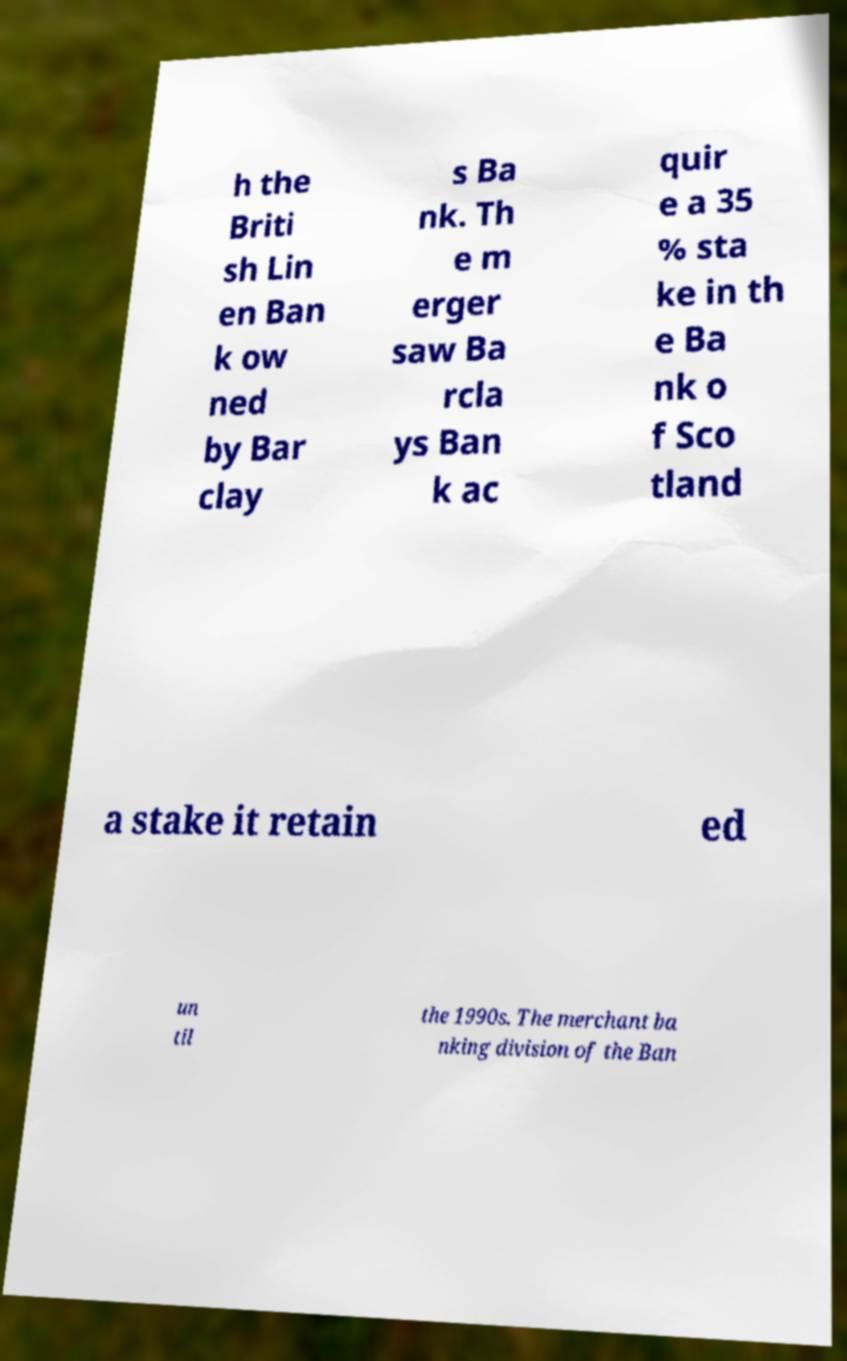There's text embedded in this image that I need extracted. Can you transcribe it verbatim? h the Briti sh Lin en Ban k ow ned by Bar clay s Ba nk. Th e m erger saw Ba rcla ys Ban k ac quir e a 35 % sta ke in th e Ba nk o f Sco tland a stake it retain ed un til the 1990s. The merchant ba nking division of the Ban 